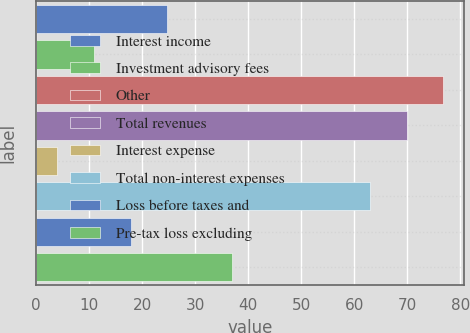<chart> <loc_0><loc_0><loc_500><loc_500><bar_chart><fcel>Interest income<fcel>Investment advisory fees<fcel>Other<fcel>Total revenues<fcel>Interest expense<fcel>Total non-interest expenses<fcel>Loss before taxes and<fcel>Pre-tax loss excluding<nl><fcel>24.7<fcel>10.9<fcel>76.8<fcel>69.9<fcel>4<fcel>63<fcel>17.8<fcel>37<nl></chart> 